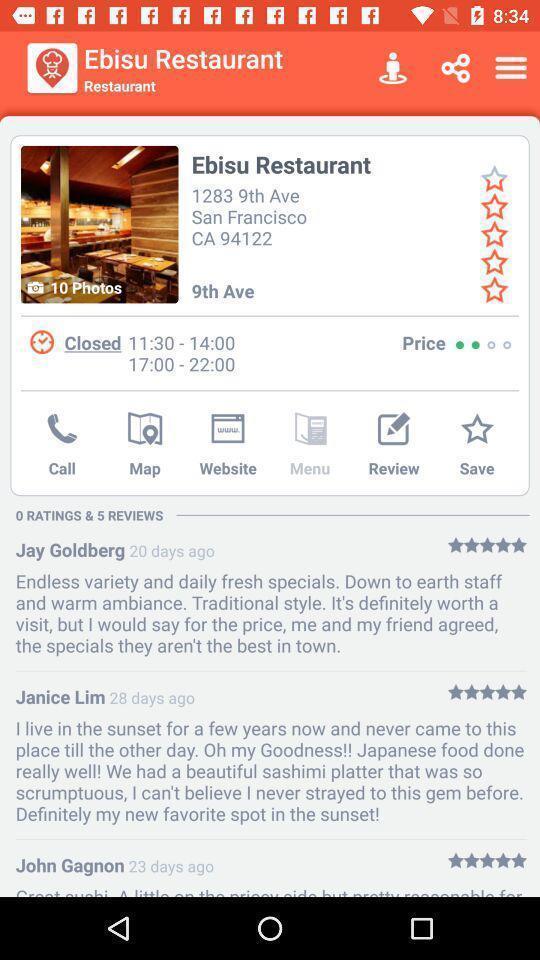What is the overall content of this screenshot? Page showing restaurant details in app. 